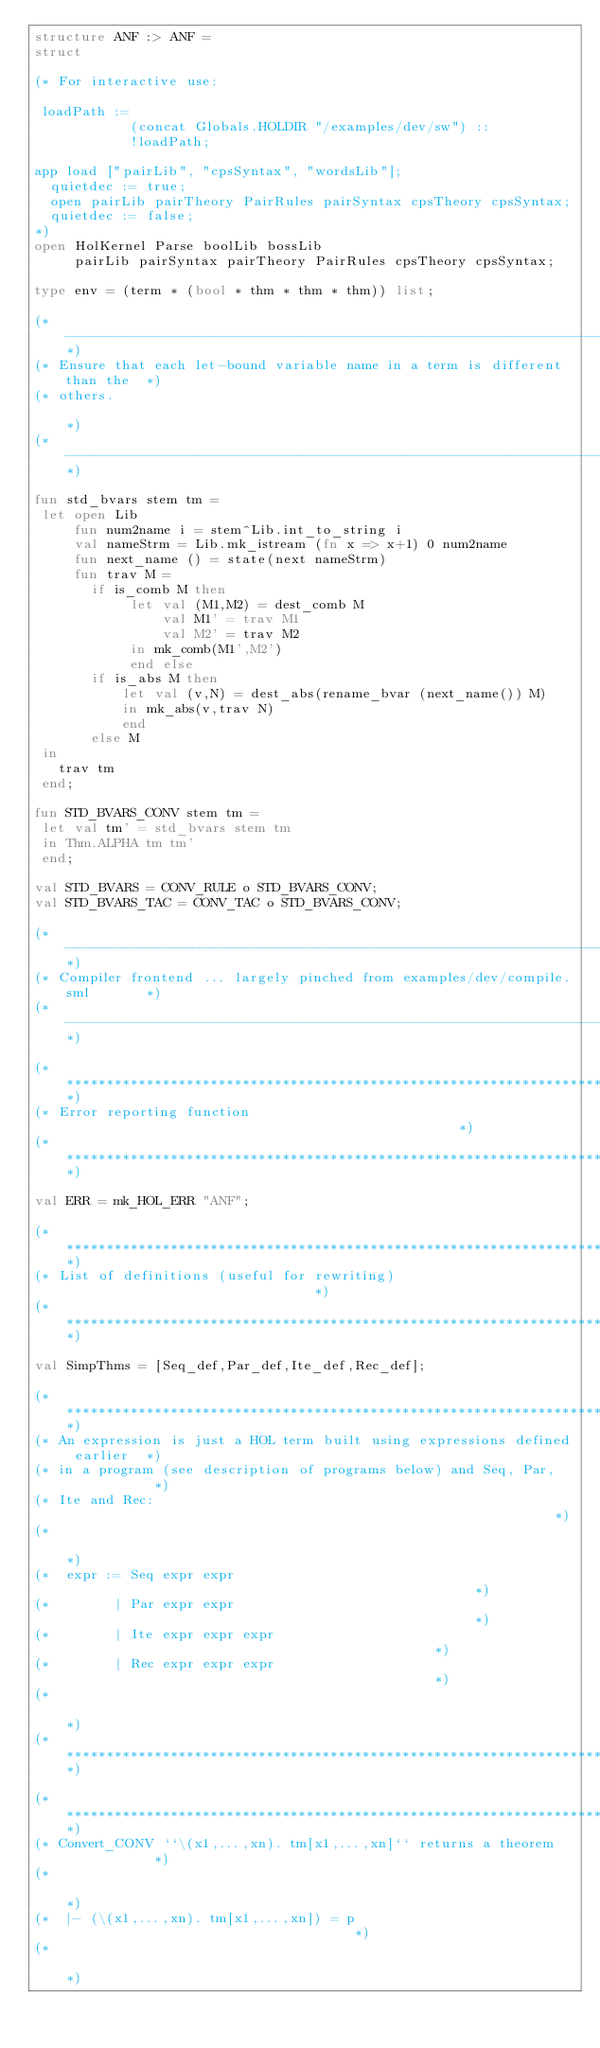Convert code to text. <code><loc_0><loc_0><loc_500><loc_500><_SML_>structure ANF :> ANF =
struct

(* For interactive use:

 loadPath :=
            (concat Globals.HOLDIR "/examples/dev/sw") ::
            !loadPath;

app load ["pairLib", "cpsSyntax", "wordsLib"];
  quietdec := true;
  open pairLib pairTheory PairRules pairSyntax cpsTheory cpsSyntax;
  quietdec := false;
*)
open HolKernel Parse boolLib bossLib
     pairLib pairSyntax pairTheory PairRules cpsTheory cpsSyntax;

type env = (term * (bool * thm * thm * thm)) list;

(*---------------------------------------------------------------------------*)
(* Ensure that each let-bound variable name in a term is different than the  *)
(* others.                                                                   *)
(*---------------------------------------------------------------------------*)

fun std_bvars stem tm =
 let open Lib
     fun num2name i = stem^Lib.int_to_string i
     val nameStrm = Lib.mk_istream (fn x => x+1) 0 num2name
     fun next_name () = state(next nameStrm)
     fun trav M =
       if is_comb M then
            let val (M1,M2) = dest_comb M
                val M1' = trav M1
                val M2' = trav M2
            in mk_comb(M1',M2')
            end else
       if is_abs M then
           let val (v,N) = dest_abs(rename_bvar (next_name()) M)
           in mk_abs(v,trav N)
           end
       else M
 in
   trav tm
 end;

fun STD_BVARS_CONV stem tm =
 let val tm' = std_bvars stem tm
 in Thm.ALPHA tm tm'
 end;

val STD_BVARS = CONV_RULE o STD_BVARS_CONV;
val STD_BVARS_TAC = CONV_TAC o STD_BVARS_CONV;

(*---------------------------------------------------------------------------*)
(* Compiler frontend ... largely pinched from examples/dev/compile.sml       *)
(*---------------------------------------------------------------------------*)

(*****************************************************************************)
(* Error reporting function                                                  *)
(*****************************************************************************)

val ERR = mk_HOL_ERR "ANF";

(*****************************************************************************)
(* List of definitions (useful for rewriting)                                *)
(*****************************************************************************)

val SimpThms = [Seq_def,Par_def,Ite_def,Rec_def];

(*****************************************************************************)
(* An expression is just a HOL term built using expressions defined earlier  *)
(* in a program (see description of programs below) and Seq, Par,            *)
(* Ite and Rec:                                                              *)
(*                                                                           *)
(*  expr := Seq expr expr                                                    *)
(*        | Par expr expr                                                    *)
(*        | Ite expr expr expr                                               *)
(*        | Rec expr expr expr                                               *)
(*                                                                           *)
(*****************************************************************************)

(*****************************************************************************)
(* Convert_CONV ``\(x1,...,xn). tm[x1,...,xn]`` returns a theorem            *)
(*                                                                           *)
(*  |- (\(x1,...,xn). tm[x1,...,xn]) = p                                     *)
(*                                                                           *)</code> 